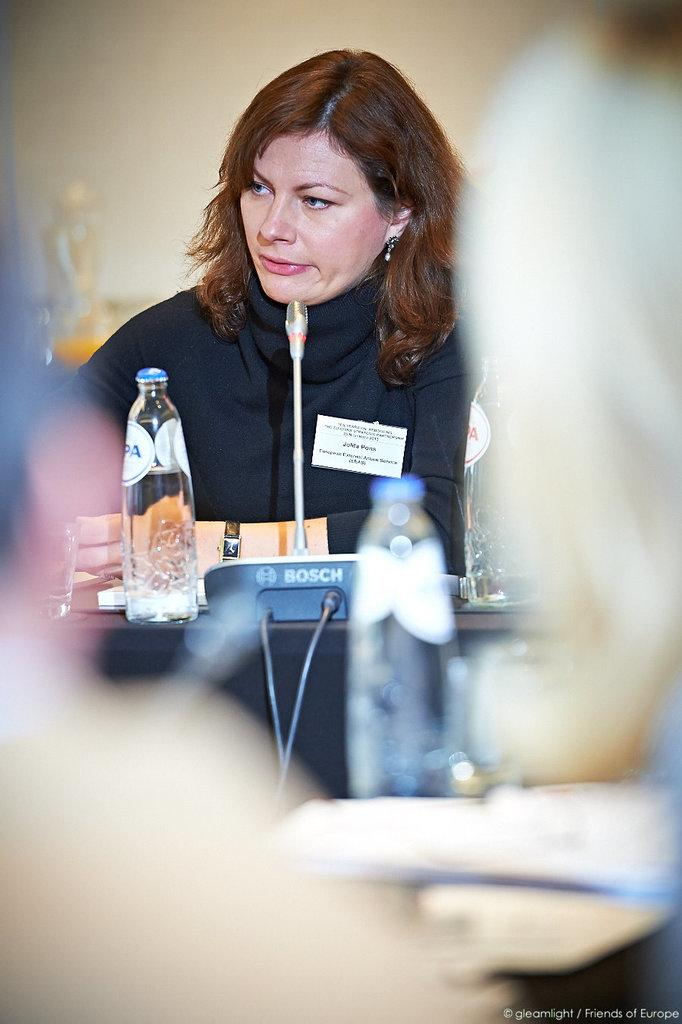Who is the main subject in the image? There is a woman in the image. What is the woman doing in the image? The woman is talking on a mic. What other objects can be seen in the image? There is a bottle, papers, and a device in the image. Can you describe the quality of the image? The image is blurry. What type of chair is the beetle sitting on in the image? There is no beetle or chair present in the image. 